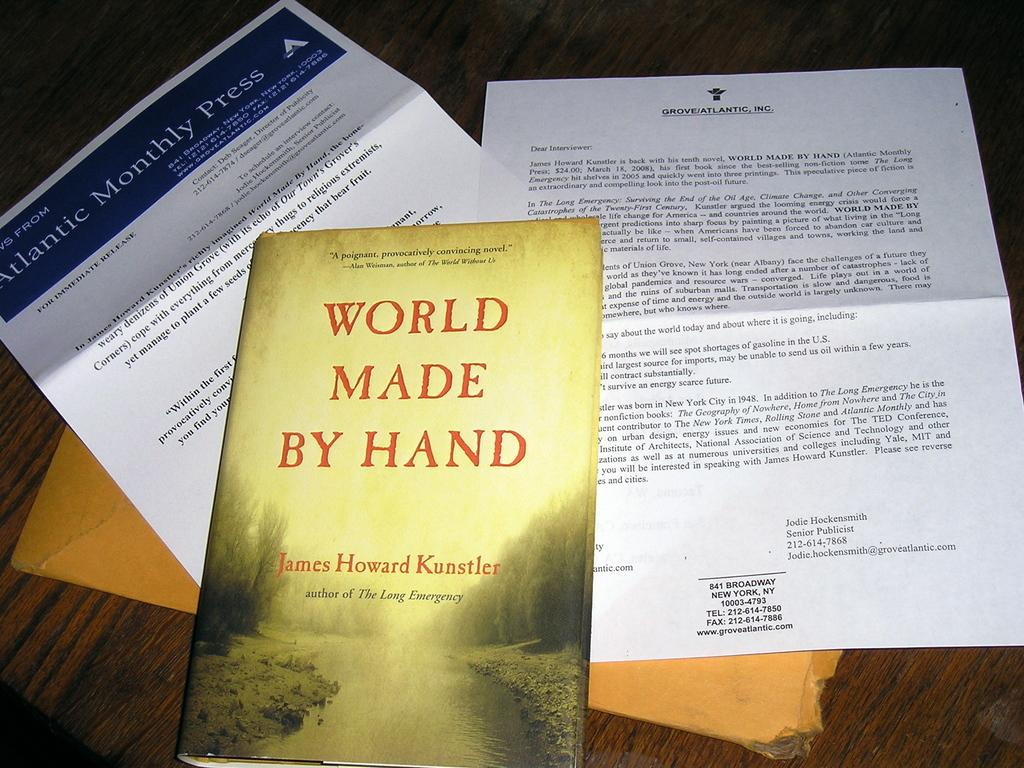<image>
Offer a succinct explanation of the picture presented. A stack of papers are under a book called World Made By Hand. 